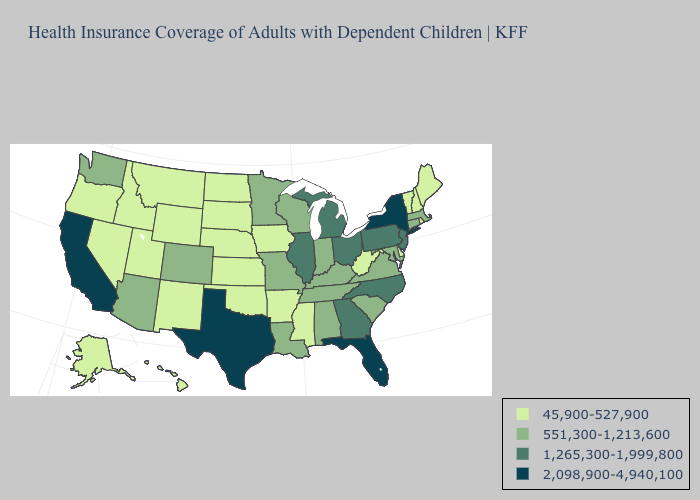Among the states that border Kansas , does Nebraska have the highest value?
Give a very brief answer. No. What is the lowest value in the USA?
Answer briefly. 45,900-527,900. How many symbols are there in the legend?
Concise answer only. 4. What is the lowest value in states that border Arizona?
Short answer required. 45,900-527,900. Name the states that have a value in the range 1,265,300-1,999,800?
Short answer required. Georgia, Illinois, Michigan, New Jersey, North Carolina, Ohio, Pennsylvania. Name the states that have a value in the range 45,900-527,900?
Keep it brief. Alaska, Arkansas, Delaware, Hawaii, Idaho, Iowa, Kansas, Maine, Mississippi, Montana, Nebraska, Nevada, New Hampshire, New Mexico, North Dakota, Oklahoma, Oregon, Rhode Island, South Dakota, Utah, Vermont, West Virginia, Wyoming. Name the states that have a value in the range 551,300-1,213,600?
Be succinct. Alabama, Arizona, Colorado, Connecticut, Indiana, Kentucky, Louisiana, Maryland, Massachusetts, Minnesota, Missouri, South Carolina, Tennessee, Virginia, Washington, Wisconsin. What is the highest value in states that border Vermont?
Quick response, please. 2,098,900-4,940,100. Does the map have missing data?
Keep it brief. No. Is the legend a continuous bar?
Be succinct. No. Which states have the highest value in the USA?
Keep it brief. California, Florida, New York, Texas. Name the states that have a value in the range 1,265,300-1,999,800?
Write a very short answer. Georgia, Illinois, Michigan, New Jersey, North Carolina, Ohio, Pennsylvania. What is the value of Hawaii?
Concise answer only. 45,900-527,900. What is the value of South Carolina?
Keep it brief. 551,300-1,213,600. What is the highest value in the South ?
Answer briefly. 2,098,900-4,940,100. 